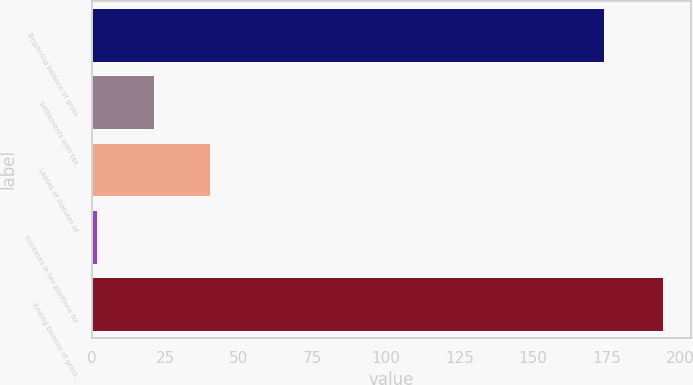Convert chart. <chart><loc_0><loc_0><loc_500><loc_500><bar_chart><fcel>Beginning balance of gross<fcel>Settlements with tax<fcel>Lapses of statutes of<fcel>Increases in tax positions for<fcel>Ending balance of gross<nl><fcel>174<fcel>21.2<fcel>40.4<fcel>2<fcel>194<nl></chart> 